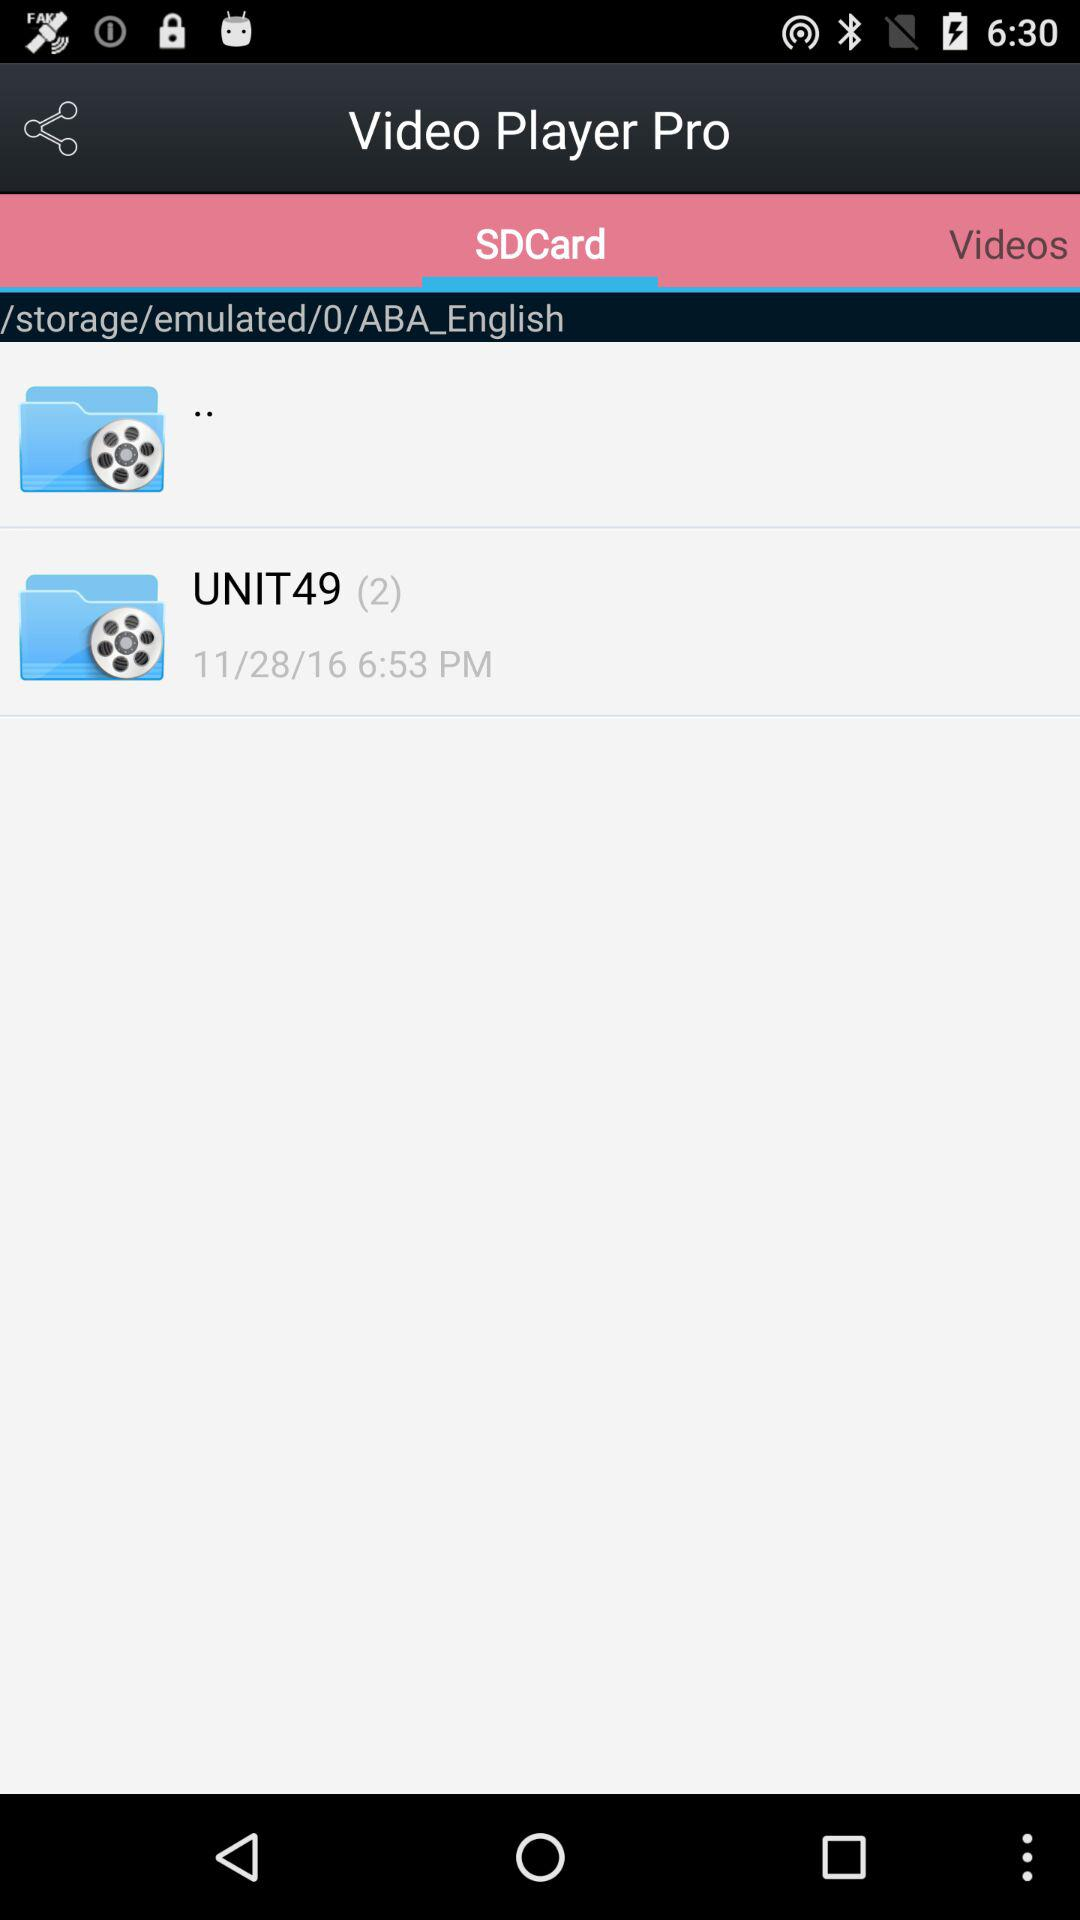What is the date given?
When the provided information is insufficient, respond with <no answer>. <no answer> 